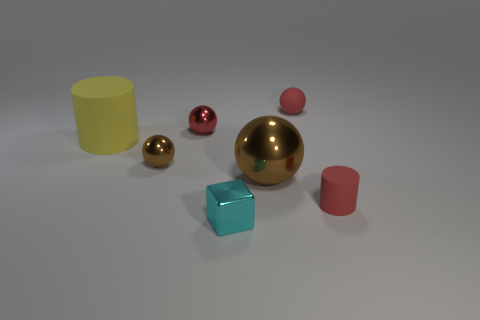Subtract all large brown shiny spheres. How many spheres are left? 3 Add 1 big gray shiny objects. How many objects exist? 8 Subtract all red cylinders. How many cylinders are left? 1 Subtract all cubes. How many objects are left? 6 Add 3 metallic objects. How many metallic objects exist? 7 Subtract 0 green balls. How many objects are left? 7 Subtract 1 cylinders. How many cylinders are left? 1 Subtract all gray cylinders. Subtract all green blocks. How many cylinders are left? 2 Subtract all brown blocks. How many brown spheres are left? 2 Subtract all spheres. Subtract all small brown shiny balls. How many objects are left? 2 